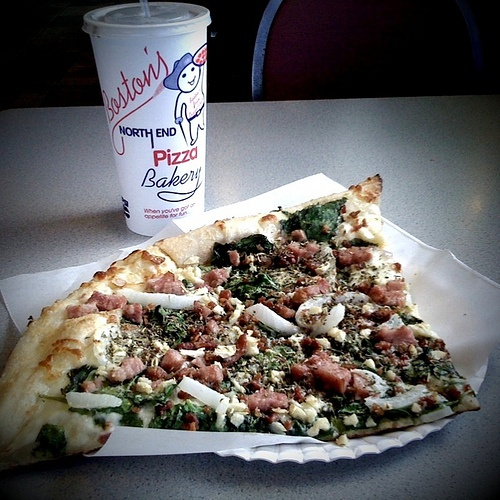Describe the objects in this image and their specific colors. I can see pizza in black, gray, ivory, and darkgray tones, chair in black, navy, darkblue, and gray tones, and cup in black, lavender, gray, and darkgray tones in this image. 